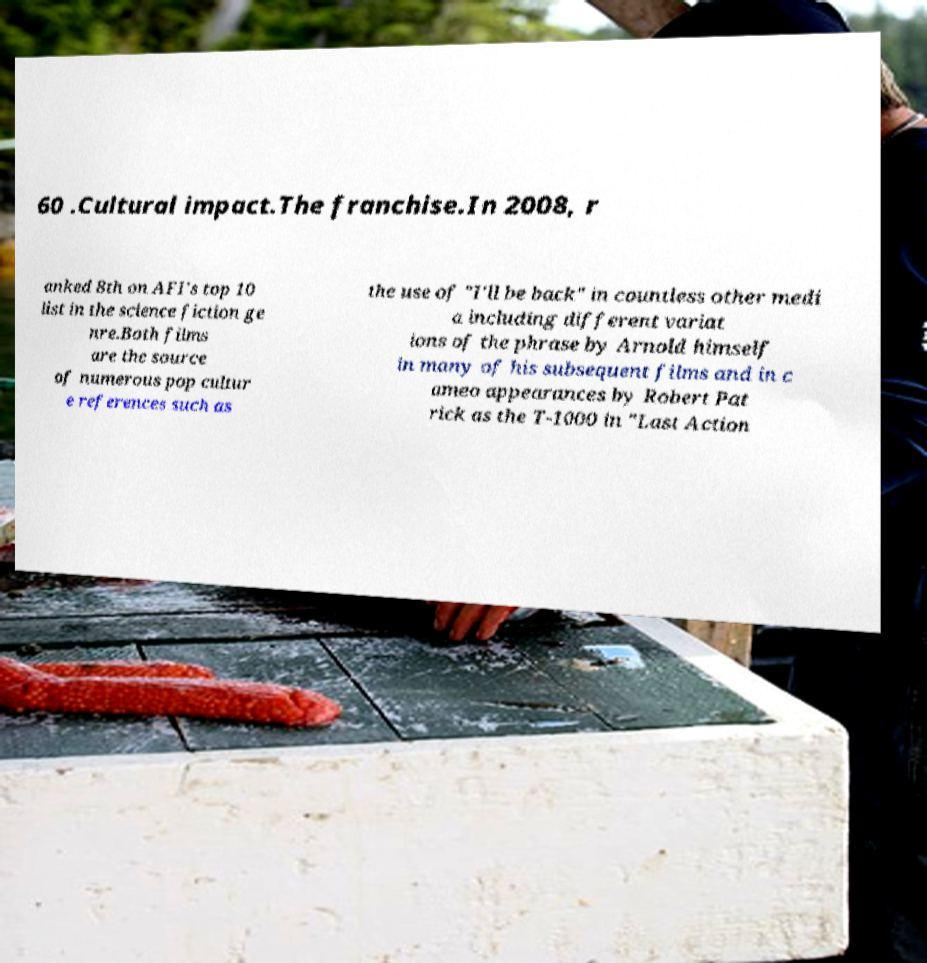For documentation purposes, I need the text within this image transcribed. Could you provide that? 60 .Cultural impact.The franchise.In 2008, r anked 8th on AFI's top 10 list in the science fiction ge nre.Both films are the source of numerous pop cultur e references such as the use of "I'll be back" in countless other medi a including different variat ions of the phrase by Arnold himself in many of his subsequent films and in c ameo appearances by Robert Pat rick as the T-1000 in "Last Action 